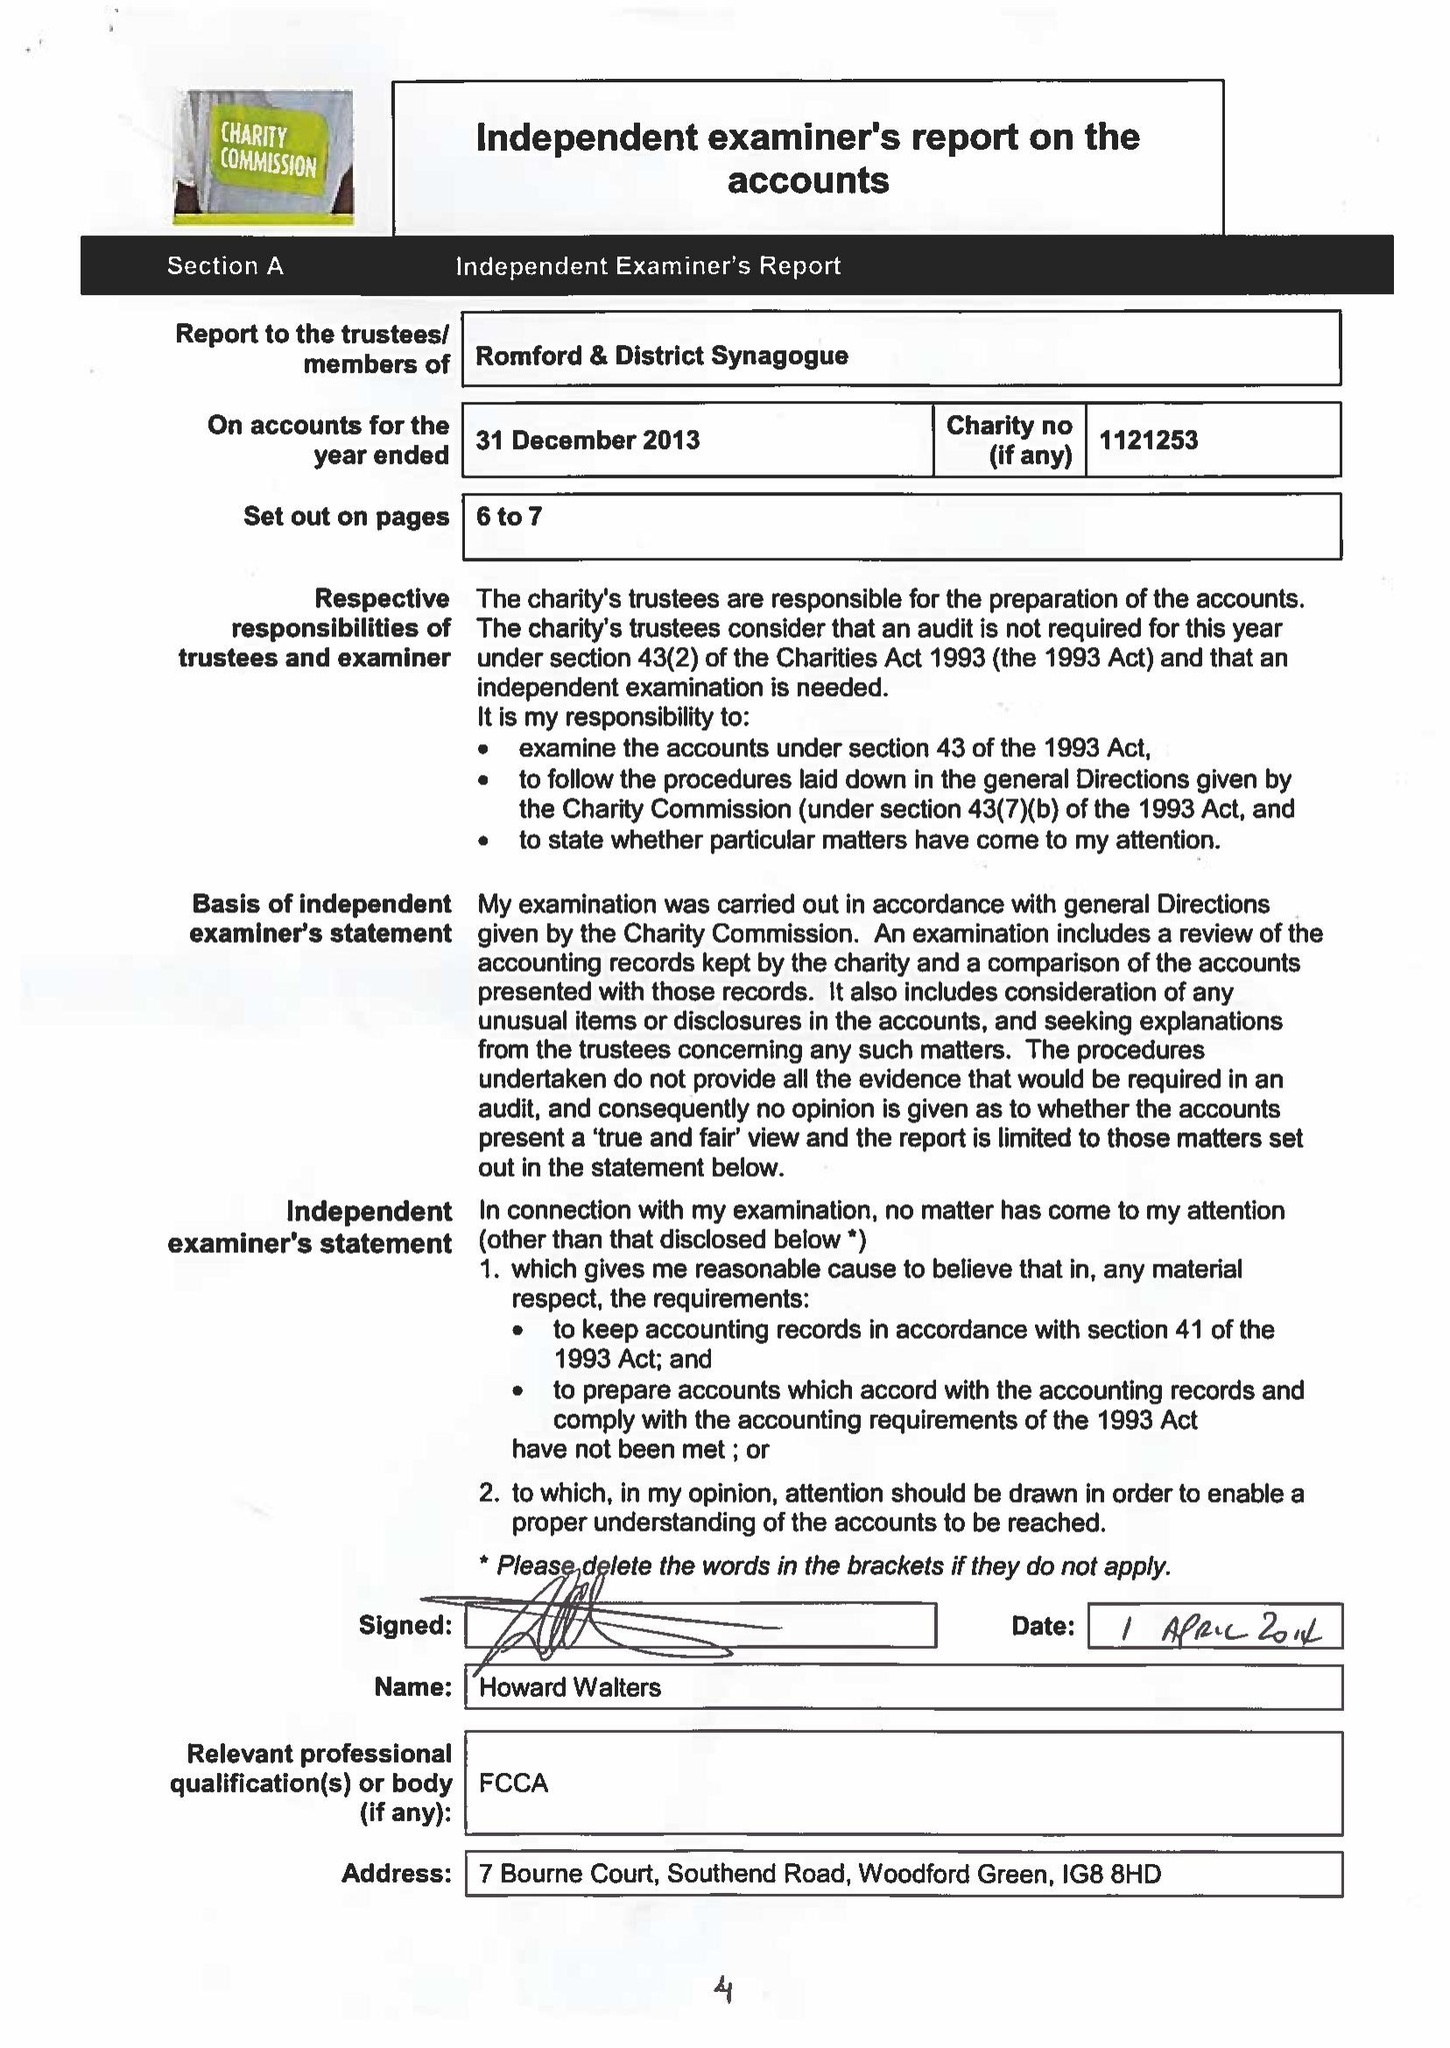What is the value for the address__post_town?
Answer the question using a single word or phrase. ROMFORD 